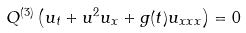<formula> <loc_0><loc_0><loc_500><loc_500>Q ^ { ( 3 ) } \left ( u _ { t } + u ^ { 2 } u _ { x } + g ( t ) u _ { x x x } \right ) = 0</formula> 